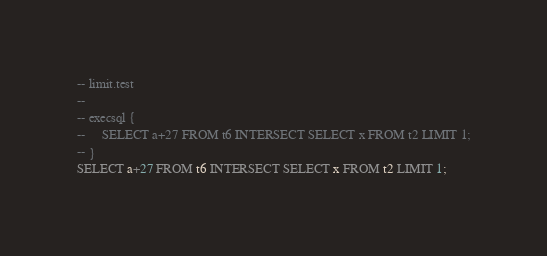<code> <loc_0><loc_0><loc_500><loc_500><_SQL_>-- limit.test
-- 
-- execsql {
--     SELECT a+27 FROM t6 INTERSECT SELECT x FROM t2 LIMIT 1;
-- }
SELECT a+27 FROM t6 INTERSECT SELECT x FROM t2 LIMIT 1;</code> 